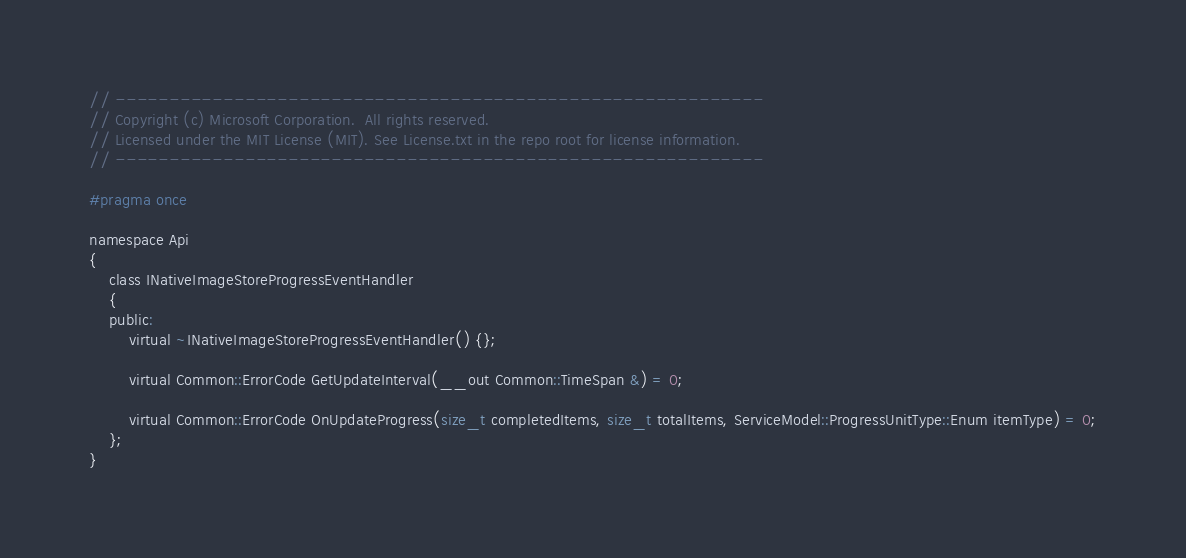Convert code to text. <code><loc_0><loc_0><loc_500><loc_500><_C_>// ------------------------------------------------------------
// Copyright (c) Microsoft Corporation.  All rights reserved.
// Licensed under the MIT License (MIT). See License.txt in the repo root for license information.
// ------------------------------------------------------------

#pragma once 

namespace Api
{
    class INativeImageStoreProgressEventHandler
    {
    public:
        virtual ~INativeImageStoreProgressEventHandler() {};

        virtual Common::ErrorCode GetUpdateInterval(__out Common::TimeSpan &) = 0;

        virtual Common::ErrorCode OnUpdateProgress(size_t completedItems, size_t totalItems, ServiceModel::ProgressUnitType::Enum itemType) = 0;
    };
}
</code> 